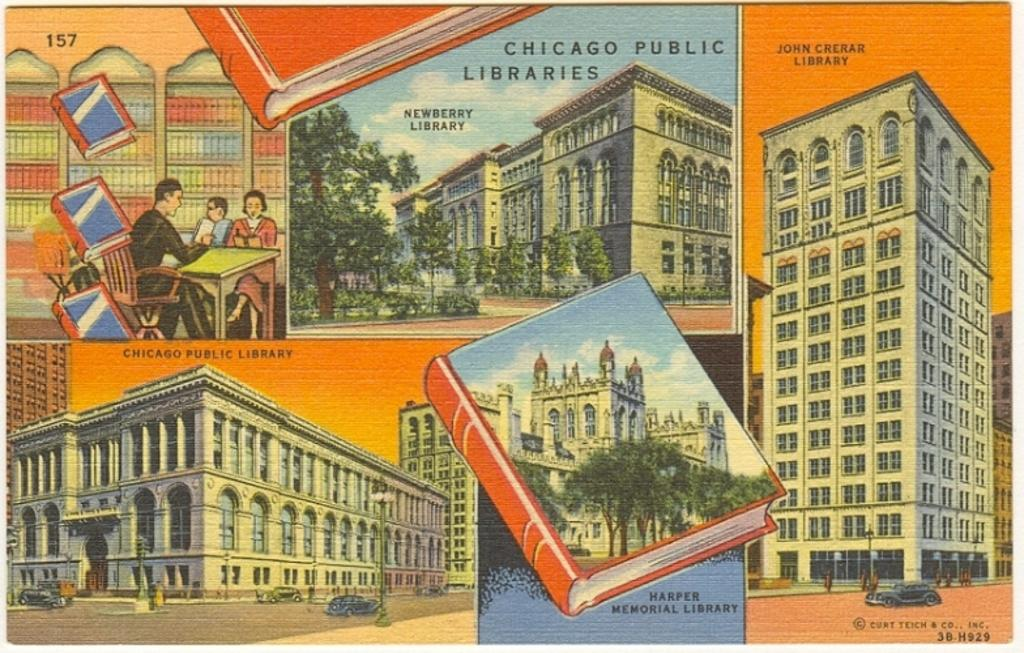What is the main subject of the poster in the image? The poster contains images of books. Are there any other images or elements on the poster? Yes, there is an image of a building on the poster. Is there any text on the poster? Yes, there is text written on the poster. How many balloons are floating in the bedroom in the image? There is no bedroom or balloons present in the image; it only features a poster with images of books, a building, and text. 